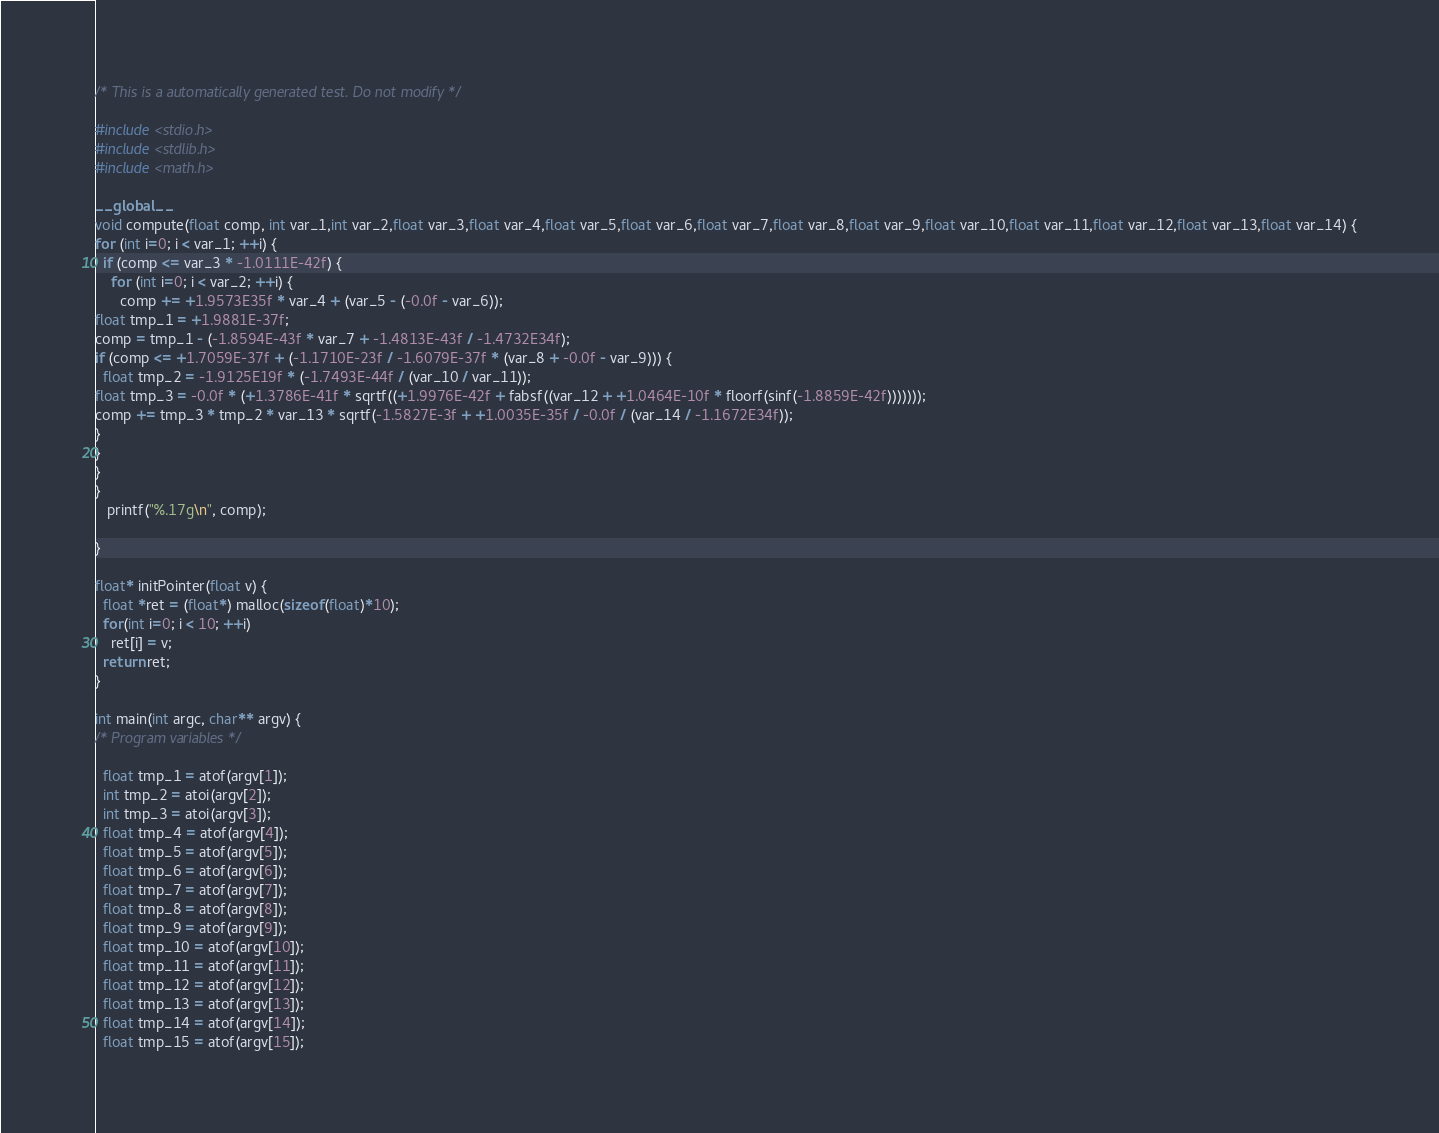<code> <loc_0><loc_0><loc_500><loc_500><_Cuda_>
/* This is a automatically generated test. Do not modify */

#include <stdio.h>
#include <stdlib.h>
#include <math.h>

__global__
void compute(float comp, int var_1,int var_2,float var_3,float var_4,float var_5,float var_6,float var_7,float var_8,float var_9,float var_10,float var_11,float var_12,float var_13,float var_14) {
for (int i=0; i < var_1; ++i) {
  if (comp <= var_3 * -1.0111E-42f) {
    for (int i=0; i < var_2; ++i) {
      comp += +1.9573E35f * var_4 + (var_5 - (-0.0f - var_6));
float tmp_1 = +1.9881E-37f;
comp = tmp_1 - (-1.8594E-43f * var_7 + -1.4813E-43f / -1.4732E34f);
if (comp <= +1.7059E-37f + (-1.1710E-23f / -1.6079E-37f * (var_8 + -0.0f - var_9))) {
  float tmp_2 = -1.9125E19f * (-1.7493E-44f / (var_10 / var_11));
float tmp_3 = -0.0f * (+1.3786E-41f * sqrtf((+1.9976E-42f + fabsf((var_12 + +1.0464E-10f * floorf(sinf(-1.8859E-42f)))))));
comp += tmp_3 * tmp_2 * var_13 * sqrtf(-1.5827E-3f + +1.0035E-35f / -0.0f / (var_14 / -1.1672E34f));
}
}
}
}
   printf("%.17g\n", comp);

}

float* initPointer(float v) {
  float *ret = (float*) malloc(sizeof(float)*10);
  for(int i=0; i < 10; ++i)
    ret[i] = v;
  return ret;
}

int main(int argc, char** argv) {
/* Program variables */

  float tmp_1 = atof(argv[1]);
  int tmp_2 = atoi(argv[2]);
  int tmp_3 = atoi(argv[3]);
  float tmp_4 = atof(argv[4]);
  float tmp_5 = atof(argv[5]);
  float tmp_6 = atof(argv[6]);
  float tmp_7 = atof(argv[7]);
  float tmp_8 = atof(argv[8]);
  float tmp_9 = atof(argv[9]);
  float tmp_10 = atof(argv[10]);
  float tmp_11 = atof(argv[11]);
  float tmp_12 = atof(argv[12]);
  float tmp_13 = atof(argv[13]);
  float tmp_14 = atof(argv[14]);
  float tmp_15 = atof(argv[15]);
</code> 